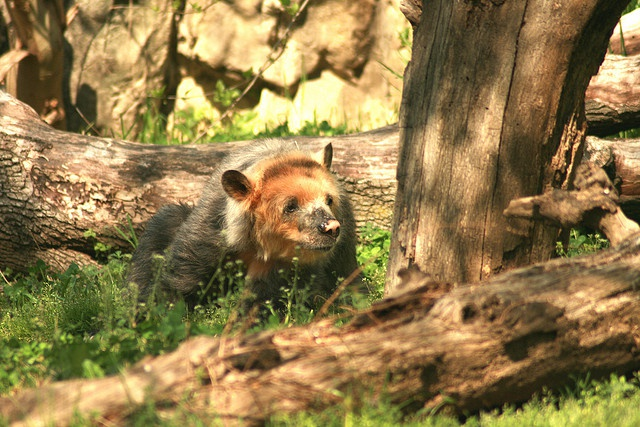Describe the objects in this image and their specific colors. I can see a bear in tan, olive, black, and khaki tones in this image. 